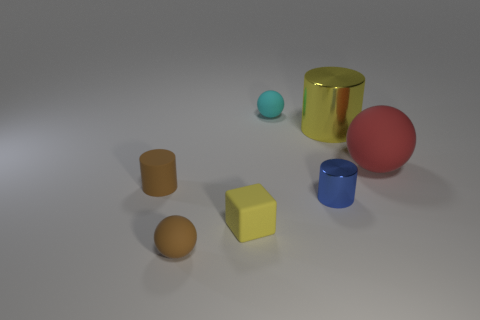Subtract all metal cylinders. How many cylinders are left? 1 Add 2 rubber cylinders. How many objects exist? 9 Add 1 tiny brown spheres. How many tiny brown spheres exist? 2 Subtract 1 brown cylinders. How many objects are left? 6 Subtract all cylinders. How many objects are left? 4 Subtract all spheres. Subtract all tiny blue cylinders. How many objects are left? 3 Add 5 yellow blocks. How many yellow blocks are left? 6 